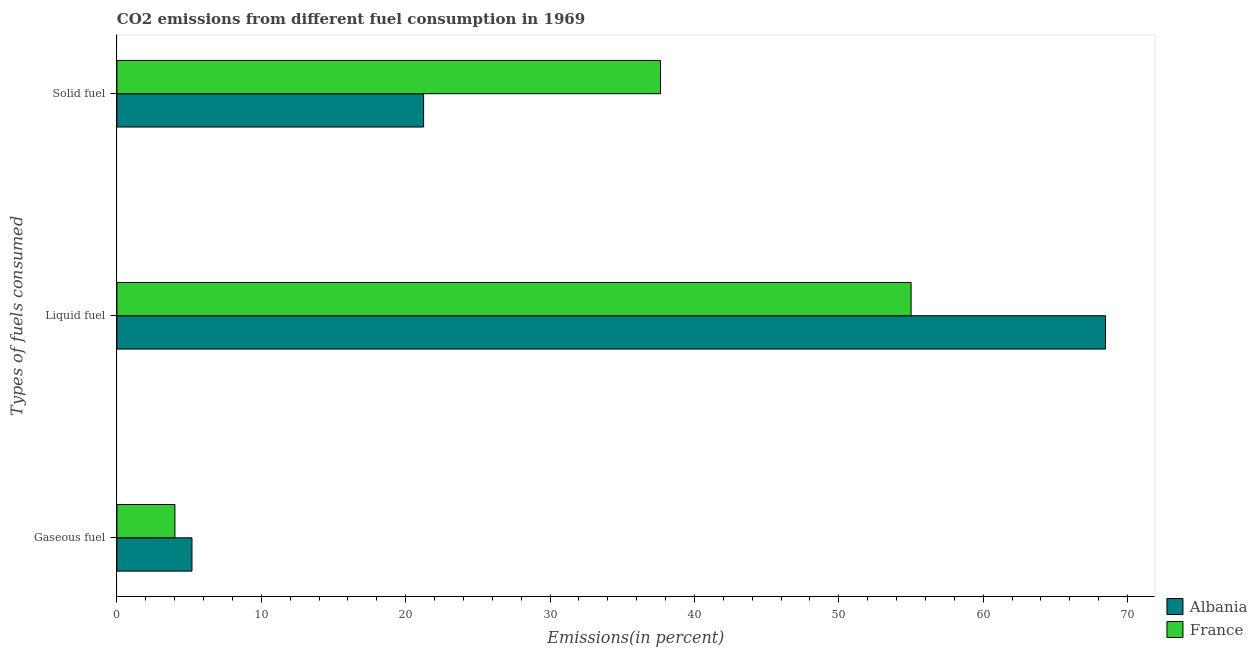How many different coloured bars are there?
Ensure brevity in your answer.  2. How many bars are there on the 3rd tick from the top?
Make the answer very short. 2. What is the label of the 1st group of bars from the top?
Make the answer very short. Solid fuel. What is the percentage of solid fuel emission in France?
Provide a succinct answer. 37.65. Across all countries, what is the maximum percentage of liquid fuel emission?
Offer a terse response. 68.47. Across all countries, what is the minimum percentage of gaseous fuel emission?
Your answer should be compact. 4.02. In which country was the percentage of gaseous fuel emission maximum?
Your answer should be very brief. Albania. What is the total percentage of solid fuel emission in the graph?
Offer a terse response. 58.89. What is the difference between the percentage of gaseous fuel emission in Albania and that in France?
Make the answer very short. 1.18. What is the difference between the percentage of liquid fuel emission in France and the percentage of gaseous fuel emission in Albania?
Give a very brief answer. 49.81. What is the average percentage of gaseous fuel emission per country?
Provide a succinct answer. 4.61. What is the difference between the percentage of liquid fuel emission and percentage of solid fuel emission in France?
Give a very brief answer. 17.36. What is the ratio of the percentage of liquid fuel emission in Albania to that in France?
Provide a short and direct response. 1.24. Is the difference between the percentage of gaseous fuel emission in Albania and France greater than the difference between the percentage of liquid fuel emission in Albania and France?
Your answer should be compact. No. What is the difference between the highest and the second highest percentage of liquid fuel emission?
Your response must be concise. 13.47. What is the difference between the highest and the lowest percentage of solid fuel emission?
Provide a short and direct response. 16.41. In how many countries, is the percentage of gaseous fuel emission greater than the average percentage of gaseous fuel emission taken over all countries?
Provide a succinct answer. 1. Is the sum of the percentage of gaseous fuel emission in Albania and France greater than the maximum percentage of liquid fuel emission across all countries?
Keep it short and to the point. No. What does the 2nd bar from the top in Solid fuel represents?
Offer a very short reply. Albania. What does the 2nd bar from the bottom in Gaseous fuel represents?
Ensure brevity in your answer.  France. Is it the case that in every country, the sum of the percentage of gaseous fuel emission and percentage of liquid fuel emission is greater than the percentage of solid fuel emission?
Offer a very short reply. Yes. How many countries are there in the graph?
Offer a terse response. 2. Are the values on the major ticks of X-axis written in scientific E-notation?
Your response must be concise. No. How many legend labels are there?
Provide a succinct answer. 2. How are the legend labels stacked?
Offer a very short reply. Vertical. What is the title of the graph?
Offer a terse response. CO2 emissions from different fuel consumption in 1969. Does "Turkey" appear as one of the legend labels in the graph?
Offer a very short reply. No. What is the label or title of the X-axis?
Your answer should be very brief. Emissions(in percent). What is the label or title of the Y-axis?
Provide a short and direct response. Types of fuels consumed. What is the Emissions(in percent) of Albania in Gaseous fuel?
Keep it short and to the point. 5.2. What is the Emissions(in percent) of France in Gaseous fuel?
Offer a terse response. 4.02. What is the Emissions(in percent) in Albania in Liquid fuel?
Make the answer very short. 68.47. What is the Emissions(in percent) of France in Liquid fuel?
Make the answer very short. 55.01. What is the Emissions(in percent) in Albania in Solid fuel?
Offer a very short reply. 21.24. What is the Emissions(in percent) in France in Solid fuel?
Provide a short and direct response. 37.65. Across all Types of fuels consumed, what is the maximum Emissions(in percent) in Albania?
Provide a short and direct response. 68.47. Across all Types of fuels consumed, what is the maximum Emissions(in percent) in France?
Offer a very short reply. 55.01. Across all Types of fuels consumed, what is the minimum Emissions(in percent) in Albania?
Offer a terse response. 5.2. Across all Types of fuels consumed, what is the minimum Emissions(in percent) of France?
Ensure brevity in your answer.  4.02. What is the total Emissions(in percent) of Albania in the graph?
Your response must be concise. 94.92. What is the total Emissions(in percent) in France in the graph?
Your answer should be compact. 96.68. What is the difference between the Emissions(in percent) of Albania in Gaseous fuel and that in Liquid fuel?
Offer a terse response. -63.28. What is the difference between the Emissions(in percent) of France in Gaseous fuel and that in Liquid fuel?
Provide a succinct answer. -50.99. What is the difference between the Emissions(in percent) of Albania in Gaseous fuel and that in Solid fuel?
Offer a terse response. -16.05. What is the difference between the Emissions(in percent) in France in Gaseous fuel and that in Solid fuel?
Give a very brief answer. -33.63. What is the difference between the Emissions(in percent) of Albania in Liquid fuel and that in Solid fuel?
Give a very brief answer. 47.23. What is the difference between the Emissions(in percent) in France in Liquid fuel and that in Solid fuel?
Ensure brevity in your answer.  17.36. What is the difference between the Emissions(in percent) in Albania in Gaseous fuel and the Emissions(in percent) in France in Liquid fuel?
Provide a succinct answer. -49.81. What is the difference between the Emissions(in percent) in Albania in Gaseous fuel and the Emissions(in percent) in France in Solid fuel?
Offer a terse response. -32.45. What is the difference between the Emissions(in percent) of Albania in Liquid fuel and the Emissions(in percent) of France in Solid fuel?
Give a very brief answer. 30.82. What is the average Emissions(in percent) of Albania per Types of fuels consumed?
Offer a terse response. 31.64. What is the average Emissions(in percent) in France per Types of fuels consumed?
Your answer should be very brief. 32.23. What is the difference between the Emissions(in percent) in Albania and Emissions(in percent) in France in Gaseous fuel?
Make the answer very short. 1.18. What is the difference between the Emissions(in percent) in Albania and Emissions(in percent) in France in Liquid fuel?
Offer a terse response. 13.47. What is the difference between the Emissions(in percent) of Albania and Emissions(in percent) of France in Solid fuel?
Provide a succinct answer. -16.41. What is the ratio of the Emissions(in percent) of Albania in Gaseous fuel to that in Liquid fuel?
Give a very brief answer. 0.08. What is the ratio of the Emissions(in percent) in France in Gaseous fuel to that in Liquid fuel?
Your response must be concise. 0.07. What is the ratio of the Emissions(in percent) of Albania in Gaseous fuel to that in Solid fuel?
Your answer should be compact. 0.24. What is the ratio of the Emissions(in percent) in France in Gaseous fuel to that in Solid fuel?
Provide a succinct answer. 0.11. What is the ratio of the Emissions(in percent) in Albania in Liquid fuel to that in Solid fuel?
Provide a succinct answer. 3.22. What is the ratio of the Emissions(in percent) of France in Liquid fuel to that in Solid fuel?
Your answer should be very brief. 1.46. What is the difference between the highest and the second highest Emissions(in percent) in Albania?
Provide a succinct answer. 47.23. What is the difference between the highest and the second highest Emissions(in percent) of France?
Your answer should be very brief. 17.36. What is the difference between the highest and the lowest Emissions(in percent) in Albania?
Make the answer very short. 63.28. What is the difference between the highest and the lowest Emissions(in percent) in France?
Ensure brevity in your answer.  50.99. 